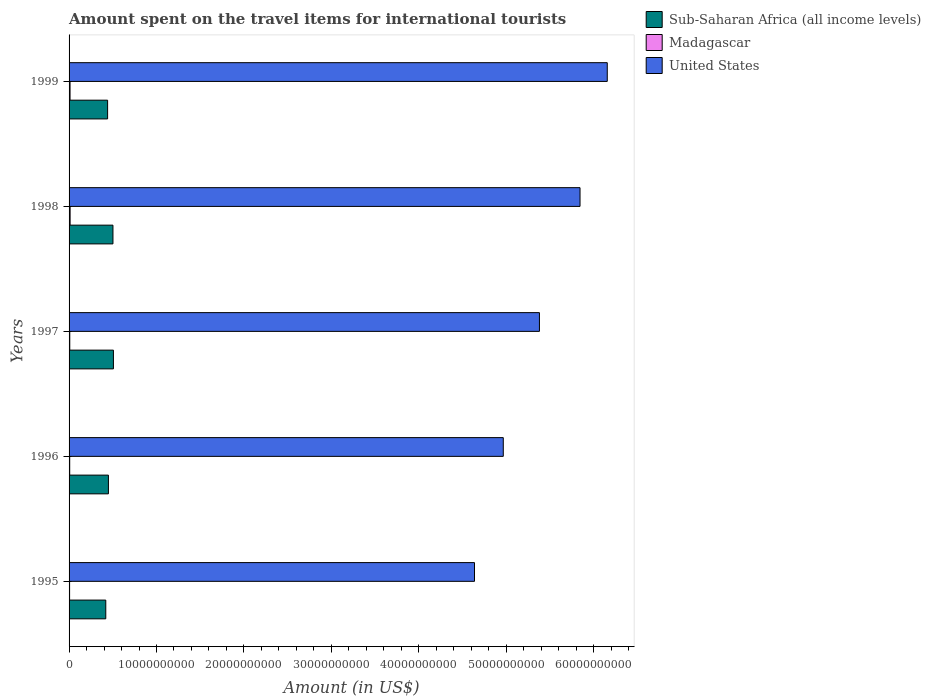How many different coloured bars are there?
Provide a succinct answer. 3. How many groups of bars are there?
Make the answer very short. 5. Are the number of bars per tick equal to the number of legend labels?
Provide a short and direct response. Yes. In how many cases, is the number of bars for a given year not equal to the number of legend labels?
Your response must be concise. 0. What is the amount spent on the travel items for international tourists in United States in 1998?
Give a very brief answer. 5.85e+1. Across all years, what is the maximum amount spent on the travel items for international tourists in Sub-Saharan Africa (all income levels)?
Provide a short and direct response. 5.07e+09. Across all years, what is the minimum amount spent on the travel items for international tourists in Sub-Saharan Africa (all income levels)?
Offer a very short reply. 4.20e+09. In which year was the amount spent on the travel items for international tourists in Madagascar minimum?
Make the answer very short. 1995. What is the total amount spent on the travel items for international tourists in Sub-Saharan Africa (all income levels) in the graph?
Make the answer very short. 2.32e+1. What is the difference between the amount spent on the travel items for international tourists in United States in 1995 and that in 1999?
Your response must be concise. -1.52e+1. What is the difference between the amount spent on the travel items for international tourists in United States in 1996 and the amount spent on the travel items for international tourists in Sub-Saharan Africa (all income levels) in 1999?
Your answer should be compact. 4.53e+1. What is the average amount spent on the travel items for international tourists in Madagascar per year?
Your answer should be very brief. 8.82e+07. In the year 1995, what is the difference between the amount spent on the travel items for international tourists in Madagascar and amount spent on the travel items for international tourists in Sub-Saharan Africa (all income levels)?
Your response must be concise. -4.14e+09. In how many years, is the amount spent on the travel items for international tourists in Madagascar greater than 2000000000 US$?
Your answer should be very brief. 0. What is the ratio of the amount spent on the travel items for international tourists in United States in 1996 to that in 1998?
Give a very brief answer. 0.85. Is the amount spent on the travel items for international tourists in Madagascar in 1996 less than that in 1999?
Make the answer very short. Yes. Is the difference between the amount spent on the travel items for international tourists in Madagascar in 1995 and 1999 greater than the difference between the amount spent on the travel items for international tourists in Sub-Saharan Africa (all income levels) in 1995 and 1999?
Keep it short and to the point. Yes. What is the difference between the highest and the second highest amount spent on the travel items for international tourists in United States?
Provide a short and direct response. 3.12e+09. What is the difference between the highest and the lowest amount spent on the travel items for international tourists in Sub-Saharan Africa (all income levels)?
Your answer should be compact. 8.74e+08. What does the 1st bar from the top in 1995 represents?
Ensure brevity in your answer.  United States. How many bars are there?
Your response must be concise. 15. Are all the bars in the graph horizontal?
Ensure brevity in your answer.  Yes. What is the difference between two consecutive major ticks on the X-axis?
Keep it short and to the point. 1.00e+1. Are the values on the major ticks of X-axis written in scientific E-notation?
Offer a terse response. No. Does the graph contain grids?
Keep it short and to the point. No. Where does the legend appear in the graph?
Provide a succinct answer. Top right. How many legend labels are there?
Ensure brevity in your answer.  3. How are the legend labels stacked?
Provide a succinct answer. Vertical. What is the title of the graph?
Give a very brief answer. Amount spent on the travel items for international tourists. Does "India" appear as one of the legend labels in the graph?
Provide a succinct answer. No. What is the label or title of the X-axis?
Your answer should be very brief. Amount (in US$). What is the label or title of the Y-axis?
Your response must be concise. Years. What is the Amount (in US$) in Sub-Saharan Africa (all income levels) in 1995?
Offer a very short reply. 4.20e+09. What is the Amount (in US$) of Madagascar in 1995?
Provide a short and direct response. 5.90e+07. What is the Amount (in US$) in United States in 1995?
Offer a terse response. 4.64e+1. What is the Amount (in US$) of Sub-Saharan Africa (all income levels) in 1996?
Give a very brief answer. 4.50e+09. What is the Amount (in US$) of Madagascar in 1996?
Provide a short and direct response. 7.20e+07. What is the Amount (in US$) of United States in 1996?
Your answer should be very brief. 4.97e+1. What is the Amount (in US$) of Sub-Saharan Africa (all income levels) in 1997?
Provide a succinct answer. 5.07e+09. What is the Amount (in US$) in Madagascar in 1997?
Offer a very short reply. 8.00e+07. What is the Amount (in US$) of United States in 1997?
Your response must be concise. 5.38e+1. What is the Amount (in US$) in Sub-Saharan Africa (all income levels) in 1998?
Make the answer very short. 5.02e+09. What is the Amount (in US$) in Madagascar in 1998?
Offer a very short reply. 1.19e+08. What is the Amount (in US$) of United States in 1998?
Keep it short and to the point. 5.85e+1. What is the Amount (in US$) of Sub-Saharan Africa (all income levels) in 1999?
Give a very brief answer. 4.41e+09. What is the Amount (in US$) of Madagascar in 1999?
Offer a very short reply. 1.11e+08. What is the Amount (in US$) in United States in 1999?
Offer a terse response. 6.16e+1. Across all years, what is the maximum Amount (in US$) of Sub-Saharan Africa (all income levels)?
Your answer should be compact. 5.07e+09. Across all years, what is the maximum Amount (in US$) of Madagascar?
Your answer should be compact. 1.19e+08. Across all years, what is the maximum Amount (in US$) of United States?
Keep it short and to the point. 6.16e+1. Across all years, what is the minimum Amount (in US$) of Sub-Saharan Africa (all income levels)?
Provide a short and direct response. 4.20e+09. Across all years, what is the minimum Amount (in US$) of Madagascar?
Offer a terse response. 5.90e+07. Across all years, what is the minimum Amount (in US$) in United States?
Offer a very short reply. 4.64e+1. What is the total Amount (in US$) of Sub-Saharan Africa (all income levels) in the graph?
Keep it short and to the point. 2.32e+1. What is the total Amount (in US$) of Madagascar in the graph?
Make the answer very short. 4.41e+08. What is the total Amount (in US$) of United States in the graph?
Provide a short and direct response. 2.70e+11. What is the difference between the Amount (in US$) of Sub-Saharan Africa (all income levels) in 1995 and that in 1996?
Your response must be concise. -3.02e+08. What is the difference between the Amount (in US$) in Madagascar in 1995 and that in 1996?
Offer a terse response. -1.30e+07. What is the difference between the Amount (in US$) in United States in 1995 and that in 1996?
Keep it short and to the point. -3.29e+09. What is the difference between the Amount (in US$) in Sub-Saharan Africa (all income levels) in 1995 and that in 1997?
Make the answer very short. -8.74e+08. What is the difference between the Amount (in US$) in Madagascar in 1995 and that in 1997?
Make the answer very short. -2.10e+07. What is the difference between the Amount (in US$) of United States in 1995 and that in 1997?
Offer a very short reply. -7.43e+09. What is the difference between the Amount (in US$) in Sub-Saharan Africa (all income levels) in 1995 and that in 1998?
Ensure brevity in your answer.  -8.20e+08. What is the difference between the Amount (in US$) in Madagascar in 1995 and that in 1998?
Your answer should be compact. -6.00e+07. What is the difference between the Amount (in US$) of United States in 1995 and that in 1998?
Your answer should be very brief. -1.21e+1. What is the difference between the Amount (in US$) of Sub-Saharan Africa (all income levels) in 1995 and that in 1999?
Your response must be concise. -2.10e+08. What is the difference between the Amount (in US$) of Madagascar in 1995 and that in 1999?
Offer a very short reply. -5.20e+07. What is the difference between the Amount (in US$) in United States in 1995 and that in 1999?
Give a very brief answer. -1.52e+1. What is the difference between the Amount (in US$) in Sub-Saharan Africa (all income levels) in 1996 and that in 1997?
Your answer should be very brief. -5.72e+08. What is the difference between the Amount (in US$) in Madagascar in 1996 and that in 1997?
Provide a succinct answer. -8.00e+06. What is the difference between the Amount (in US$) in United States in 1996 and that in 1997?
Offer a terse response. -4.14e+09. What is the difference between the Amount (in US$) of Sub-Saharan Africa (all income levels) in 1996 and that in 1998?
Make the answer very short. -5.18e+08. What is the difference between the Amount (in US$) in Madagascar in 1996 and that in 1998?
Keep it short and to the point. -4.70e+07. What is the difference between the Amount (in US$) of United States in 1996 and that in 1998?
Give a very brief answer. -8.78e+09. What is the difference between the Amount (in US$) in Sub-Saharan Africa (all income levels) in 1996 and that in 1999?
Ensure brevity in your answer.  9.26e+07. What is the difference between the Amount (in US$) in Madagascar in 1996 and that in 1999?
Provide a short and direct response. -3.90e+07. What is the difference between the Amount (in US$) of United States in 1996 and that in 1999?
Offer a very short reply. -1.19e+1. What is the difference between the Amount (in US$) of Sub-Saharan Africa (all income levels) in 1997 and that in 1998?
Your answer should be compact. 5.43e+07. What is the difference between the Amount (in US$) of Madagascar in 1997 and that in 1998?
Your answer should be compact. -3.90e+07. What is the difference between the Amount (in US$) in United States in 1997 and that in 1998?
Offer a very short reply. -4.64e+09. What is the difference between the Amount (in US$) in Sub-Saharan Africa (all income levels) in 1997 and that in 1999?
Give a very brief answer. 6.65e+08. What is the difference between the Amount (in US$) in Madagascar in 1997 and that in 1999?
Your answer should be compact. -3.10e+07. What is the difference between the Amount (in US$) in United States in 1997 and that in 1999?
Make the answer very short. -7.76e+09. What is the difference between the Amount (in US$) in Sub-Saharan Africa (all income levels) in 1998 and that in 1999?
Provide a succinct answer. 6.11e+08. What is the difference between the Amount (in US$) in United States in 1998 and that in 1999?
Offer a terse response. -3.12e+09. What is the difference between the Amount (in US$) of Sub-Saharan Africa (all income levels) in 1995 and the Amount (in US$) of Madagascar in 1996?
Keep it short and to the point. 4.13e+09. What is the difference between the Amount (in US$) in Sub-Saharan Africa (all income levels) in 1995 and the Amount (in US$) in United States in 1996?
Give a very brief answer. -4.55e+1. What is the difference between the Amount (in US$) in Madagascar in 1995 and the Amount (in US$) in United States in 1996?
Provide a succinct answer. -4.96e+1. What is the difference between the Amount (in US$) in Sub-Saharan Africa (all income levels) in 1995 and the Amount (in US$) in Madagascar in 1997?
Your response must be concise. 4.12e+09. What is the difference between the Amount (in US$) of Sub-Saharan Africa (all income levels) in 1995 and the Amount (in US$) of United States in 1997?
Offer a very short reply. -4.96e+1. What is the difference between the Amount (in US$) in Madagascar in 1995 and the Amount (in US$) in United States in 1997?
Provide a succinct answer. -5.37e+1. What is the difference between the Amount (in US$) of Sub-Saharan Africa (all income levels) in 1995 and the Amount (in US$) of Madagascar in 1998?
Your response must be concise. 4.08e+09. What is the difference between the Amount (in US$) of Sub-Saharan Africa (all income levels) in 1995 and the Amount (in US$) of United States in 1998?
Keep it short and to the point. -5.43e+1. What is the difference between the Amount (in US$) of Madagascar in 1995 and the Amount (in US$) of United States in 1998?
Provide a short and direct response. -5.84e+1. What is the difference between the Amount (in US$) in Sub-Saharan Africa (all income levels) in 1995 and the Amount (in US$) in Madagascar in 1999?
Keep it short and to the point. 4.09e+09. What is the difference between the Amount (in US$) of Sub-Saharan Africa (all income levels) in 1995 and the Amount (in US$) of United States in 1999?
Keep it short and to the point. -5.74e+1. What is the difference between the Amount (in US$) of Madagascar in 1995 and the Amount (in US$) of United States in 1999?
Provide a short and direct response. -6.15e+1. What is the difference between the Amount (in US$) in Sub-Saharan Africa (all income levels) in 1996 and the Amount (in US$) in Madagascar in 1997?
Give a very brief answer. 4.42e+09. What is the difference between the Amount (in US$) in Sub-Saharan Africa (all income levels) in 1996 and the Amount (in US$) in United States in 1997?
Provide a short and direct response. -4.93e+1. What is the difference between the Amount (in US$) of Madagascar in 1996 and the Amount (in US$) of United States in 1997?
Ensure brevity in your answer.  -5.37e+1. What is the difference between the Amount (in US$) in Sub-Saharan Africa (all income levels) in 1996 and the Amount (in US$) in Madagascar in 1998?
Keep it short and to the point. 4.38e+09. What is the difference between the Amount (in US$) of Sub-Saharan Africa (all income levels) in 1996 and the Amount (in US$) of United States in 1998?
Offer a terse response. -5.39e+1. What is the difference between the Amount (in US$) of Madagascar in 1996 and the Amount (in US$) of United States in 1998?
Your answer should be compact. -5.84e+1. What is the difference between the Amount (in US$) of Sub-Saharan Africa (all income levels) in 1996 and the Amount (in US$) of Madagascar in 1999?
Provide a short and direct response. 4.39e+09. What is the difference between the Amount (in US$) in Sub-Saharan Africa (all income levels) in 1996 and the Amount (in US$) in United States in 1999?
Provide a short and direct response. -5.71e+1. What is the difference between the Amount (in US$) in Madagascar in 1996 and the Amount (in US$) in United States in 1999?
Offer a terse response. -6.15e+1. What is the difference between the Amount (in US$) in Sub-Saharan Africa (all income levels) in 1997 and the Amount (in US$) in Madagascar in 1998?
Your answer should be very brief. 4.95e+09. What is the difference between the Amount (in US$) of Sub-Saharan Africa (all income levels) in 1997 and the Amount (in US$) of United States in 1998?
Offer a very short reply. -5.34e+1. What is the difference between the Amount (in US$) in Madagascar in 1997 and the Amount (in US$) in United States in 1998?
Provide a succinct answer. -5.84e+1. What is the difference between the Amount (in US$) in Sub-Saharan Africa (all income levels) in 1997 and the Amount (in US$) in Madagascar in 1999?
Keep it short and to the point. 4.96e+09. What is the difference between the Amount (in US$) in Sub-Saharan Africa (all income levels) in 1997 and the Amount (in US$) in United States in 1999?
Offer a terse response. -5.65e+1. What is the difference between the Amount (in US$) of Madagascar in 1997 and the Amount (in US$) of United States in 1999?
Your answer should be very brief. -6.15e+1. What is the difference between the Amount (in US$) in Sub-Saharan Africa (all income levels) in 1998 and the Amount (in US$) in Madagascar in 1999?
Your answer should be very brief. 4.91e+09. What is the difference between the Amount (in US$) in Sub-Saharan Africa (all income levels) in 1998 and the Amount (in US$) in United States in 1999?
Make the answer very short. -5.65e+1. What is the difference between the Amount (in US$) of Madagascar in 1998 and the Amount (in US$) of United States in 1999?
Ensure brevity in your answer.  -6.14e+1. What is the average Amount (in US$) in Sub-Saharan Africa (all income levels) per year?
Offer a very short reply. 4.64e+09. What is the average Amount (in US$) of Madagascar per year?
Keep it short and to the point. 8.82e+07. What is the average Amount (in US$) of United States per year?
Make the answer very short. 5.40e+1. In the year 1995, what is the difference between the Amount (in US$) in Sub-Saharan Africa (all income levels) and Amount (in US$) in Madagascar?
Provide a succinct answer. 4.14e+09. In the year 1995, what is the difference between the Amount (in US$) in Sub-Saharan Africa (all income levels) and Amount (in US$) in United States?
Make the answer very short. -4.22e+1. In the year 1995, what is the difference between the Amount (in US$) in Madagascar and Amount (in US$) in United States?
Your answer should be very brief. -4.63e+1. In the year 1996, what is the difference between the Amount (in US$) of Sub-Saharan Africa (all income levels) and Amount (in US$) of Madagascar?
Make the answer very short. 4.43e+09. In the year 1996, what is the difference between the Amount (in US$) of Sub-Saharan Africa (all income levels) and Amount (in US$) of United States?
Your answer should be very brief. -4.52e+1. In the year 1996, what is the difference between the Amount (in US$) in Madagascar and Amount (in US$) in United States?
Your answer should be very brief. -4.96e+1. In the year 1997, what is the difference between the Amount (in US$) in Sub-Saharan Africa (all income levels) and Amount (in US$) in Madagascar?
Give a very brief answer. 4.99e+09. In the year 1997, what is the difference between the Amount (in US$) in Sub-Saharan Africa (all income levels) and Amount (in US$) in United States?
Keep it short and to the point. -4.87e+1. In the year 1997, what is the difference between the Amount (in US$) of Madagascar and Amount (in US$) of United States?
Your response must be concise. -5.37e+1. In the year 1998, what is the difference between the Amount (in US$) in Sub-Saharan Africa (all income levels) and Amount (in US$) in Madagascar?
Keep it short and to the point. 4.90e+09. In the year 1998, what is the difference between the Amount (in US$) in Sub-Saharan Africa (all income levels) and Amount (in US$) in United States?
Ensure brevity in your answer.  -5.34e+1. In the year 1998, what is the difference between the Amount (in US$) in Madagascar and Amount (in US$) in United States?
Make the answer very short. -5.83e+1. In the year 1999, what is the difference between the Amount (in US$) in Sub-Saharan Africa (all income levels) and Amount (in US$) in Madagascar?
Provide a short and direct response. 4.30e+09. In the year 1999, what is the difference between the Amount (in US$) of Sub-Saharan Africa (all income levels) and Amount (in US$) of United States?
Keep it short and to the point. -5.72e+1. In the year 1999, what is the difference between the Amount (in US$) in Madagascar and Amount (in US$) in United States?
Your response must be concise. -6.15e+1. What is the ratio of the Amount (in US$) of Sub-Saharan Africa (all income levels) in 1995 to that in 1996?
Your answer should be compact. 0.93. What is the ratio of the Amount (in US$) in Madagascar in 1995 to that in 1996?
Your answer should be very brief. 0.82. What is the ratio of the Amount (in US$) of United States in 1995 to that in 1996?
Your answer should be compact. 0.93. What is the ratio of the Amount (in US$) in Sub-Saharan Africa (all income levels) in 1995 to that in 1997?
Provide a short and direct response. 0.83. What is the ratio of the Amount (in US$) of Madagascar in 1995 to that in 1997?
Provide a short and direct response. 0.74. What is the ratio of the Amount (in US$) in United States in 1995 to that in 1997?
Your answer should be compact. 0.86. What is the ratio of the Amount (in US$) of Sub-Saharan Africa (all income levels) in 1995 to that in 1998?
Your answer should be very brief. 0.84. What is the ratio of the Amount (in US$) of Madagascar in 1995 to that in 1998?
Ensure brevity in your answer.  0.5. What is the ratio of the Amount (in US$) of United States in 1995 to that in 1998?
Keep it short and to the point. 0.79. What is the ratio of the Amount (in US$) in Madagascar in 1995 to that in 1999?
Provide a succinct answer. 0.53. What is the ratio of the Amount (in US$) in United States in 1995 to that in 1999?
Make the answer very short. 0.75. What is the ratio of the Amount (in US$) in Sub-Saharan Africa (all income levels) in 1996 to that in 1997?
Offer a very short reply. 0.89. What is the ratio of the Amount (in US$) of United States in 1996 to that in 1997?
Offer a very short reply. 0.92. What is the ratio of the Amount (in US$) of Sub-Saharan Africa (all income levels) in 1996 to that in 1998?
Your answer should be very brief. 0.9. What is the ratio of the Amount (in US$) in Madagascar in 1996 to that in 1998?
Make the answer very short. 0.6. What is the ratio of the Amount (in US$) in United States in 1996 to that in 1998?
Give a very brief answer. 0.85. What is the ratio of the Amount (in US$) of Sub-Saharan Africa (all income levels) in 1996 to that in 1999?
Make the answer very short. 1.02. What is the ratio of the Amount (in US$) of Madagascar in 1996 to that in 1999?
Make the answer very short. 0.65. What is the ratio of the Amount (in US$) in United States in 1996 to that in 1999?
Make the answer very short. 0.81. What is the ratio of the Amount (in US$) of Sub-Saharan Africa (all income levels) in 1997 to that in 1998?
Your response must be concise. 1.01. What is the ratio of the Amount (in US$) of Madagascar in 1997 to that in 1998?
Ensure brevity in your answer.  0.67. What is the ratio of the Amount (in US$) in United States in 1997 to that in 1998?
Provide a short and direct response. 0.92. What is the ratio of the Amount (in US$) in Sub-Saharan Africa (all income levels) in 1997 to that in 1999?
Provide a short and direct response. 1.15. What is the ratio of the Amount (in US$) in Madagascar in 1997 to that in 1999?
Offer a very short reply. 0.72. What is the ratio of the Amount (in US$) of United States in 1997 to that in 1999?
Give a very brief answer. 0.87. What is the ratio of the Amount (in US$) in Sub-Saharan Africa (all income levels) in 1998 to that in 1999?
Provide a succinct answer. 1.14. What is the ratio of the Amount (in US$) of Madagascar in 1998 to that in 1999?
Ensure brevity in your answer.  1.07. What is the ratio of the Amount (in US$) of United States in 1998 to that in 1999?
Make the answer very short. 0.95. What is the difference between the highest and the second highest Amount (in US$) in Sub-Saharan Africa (all income levels)?
Your response must be concise. 5.43e+07. What is the difference between the highest and the second highest Amount (in US$) of Madagascar?
Offer a very short reply. 8.00e+06. What is the difference between the highest and the second highest Amount (in US$) in United States?
Make the answer very short. 3.12e+09. What is the difference between the highest and the lowest Amount (in US$) of Sub-Saharan Africa (all income levels)?
Your answer should be compact. 8.74e+08. What is the difference between the highest and the lowest Amount (in US$) in Madagascar?
Offer a very short reply. 6.00e+07. What is the difference between the highest and the lowest Amount (in US$) of United States?
Your answer should be very brief. 1.52e+1. 